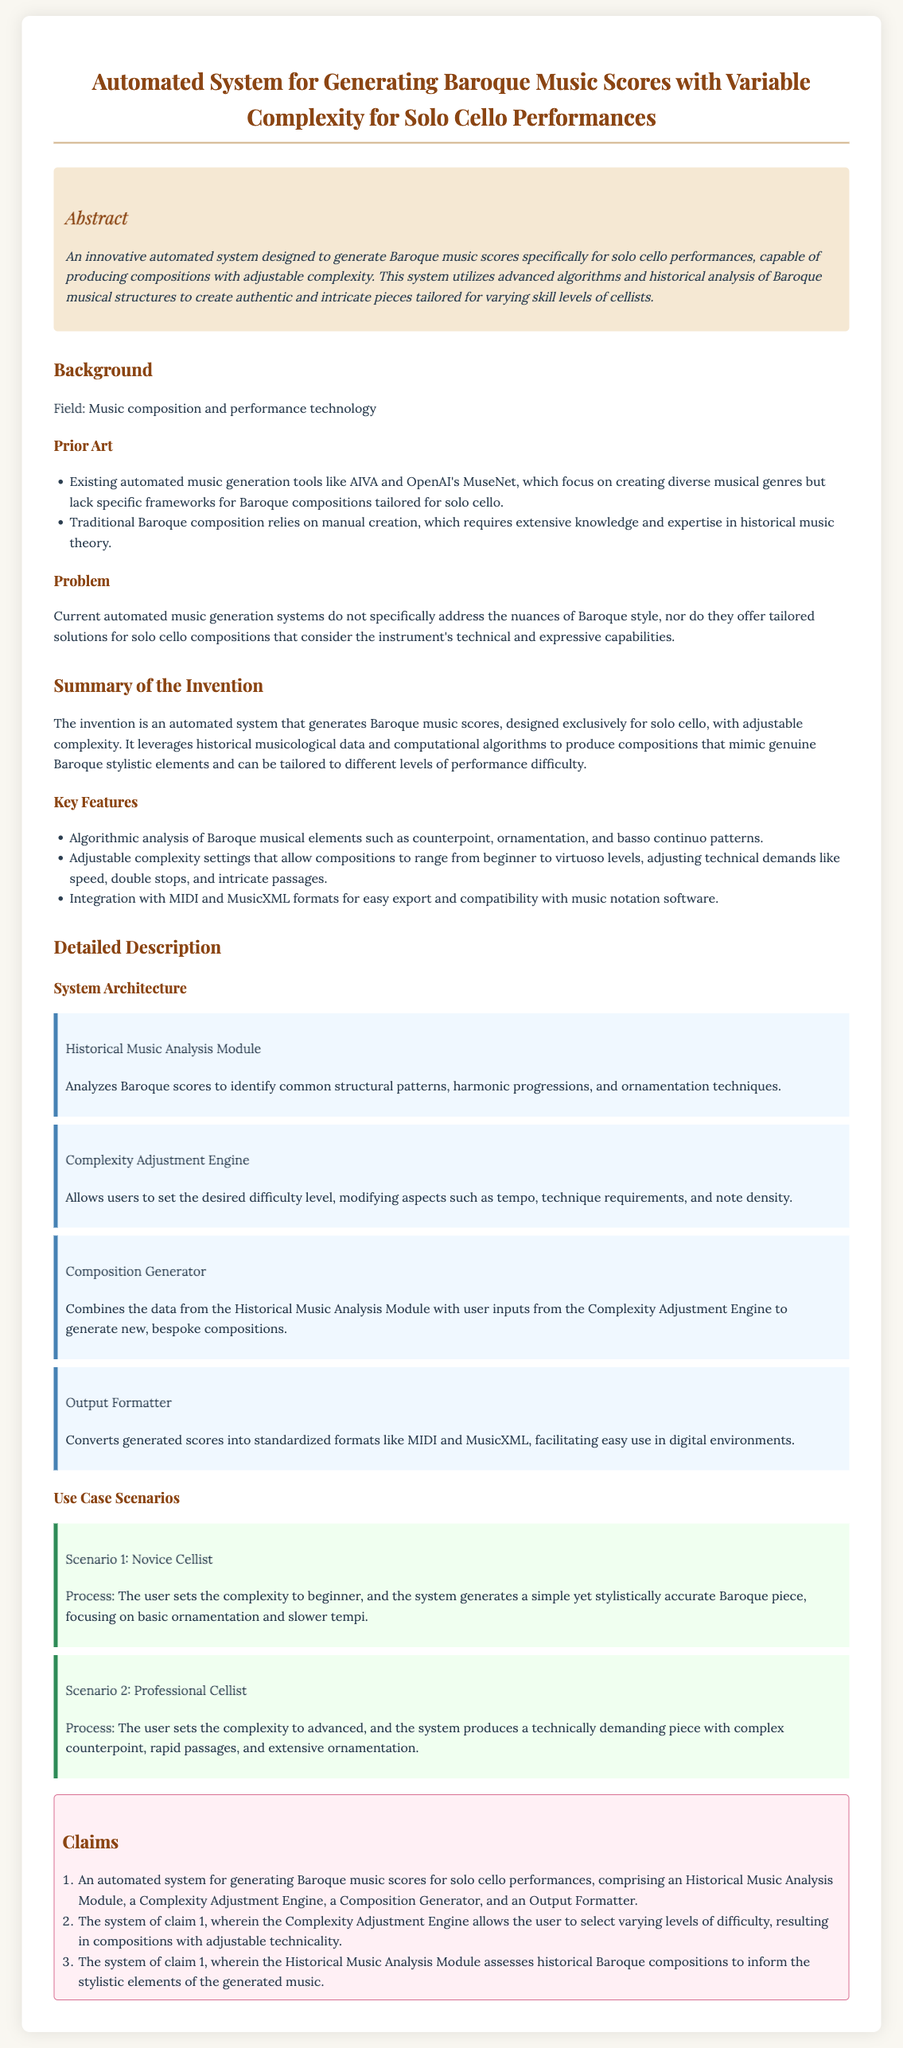What is the title of the patent application? The title of the patent application is stated at the top of the document.
Answer: Automated System for Generating Baroque Music Scores with Variable Complexity for Solo Cello Performances What is the primary field of this patent? The field is mentioned in the Background section of the document.
Answer: Music composition and performance technology What key feature allows the user to modify the composition's difficulty? The key feature is outlined in the Summary of the Invention section.
Answer: Complexity Adjustment Engine How many scenarios are provided in the document? The number of scenarios is listed under the Use Case Scenarios section.
Answer: Two What does the Composition Generator do? The function of the Composition Generator is described in the Detailed Description section.
Answer: Generates new, bespoke compositions Which software formats does the Output Formatter support? The supported formats are mentioned in the Key Features list.
Answer: MIDI and MusicXML How many claims are made in the patent application? The number of claims is stated at the beginning of the Claims section.
Answer: Three What types of compositions does this system specifically target? The target compositions are specified in the Abstract section of the document.
Answer: Baroque music scores for solo cello What type of element does the Historical Music Analysis Module focus on? The focus of the Historical Music Analysis Module is detailed in the Detailed Description section.
Answer: Structural patterns, harmonic progressions, and ornamentation techniques 